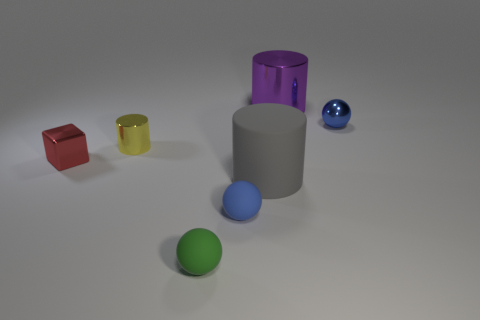Are there fewer cylinders on the right side of the blue metallic object than small yellow cylinders that are in front of the gray matte object?
Offer a very short reply. No. There is another large object that is the same shape as the big gray thing; what color is it?
Your answer should be compact. Purple. Do the cylinder in front of the red shiny thing and the red shiny object have the same size?
Offer a very short reply. No. Are there fewer large purple things behind the blue matte ball than small blue metal balls?
Keep it short and to the point. No. Are there any other things that have the same size as the blue matte thing?
Provide a succinct answer. Yes. How big is the object in front of the blue thing on the left side of the gray matte cylinder?
Your response must be concise. Small. Are there any other things that have the same shape as the blue matte thing?
Give a very brief answer. Yes. Are there fewer big purple metal cylinders than metallic objects?
Your answer should be compact. Yes. There is a thing that is behind the green object and in front of the gray cylinder; what material is it?
Offer a terse response. Rubber. There is a large thing to the left of the purple thing; are there any small blue spheres that are to the left of it?
Give a very brief answer. Yes. 